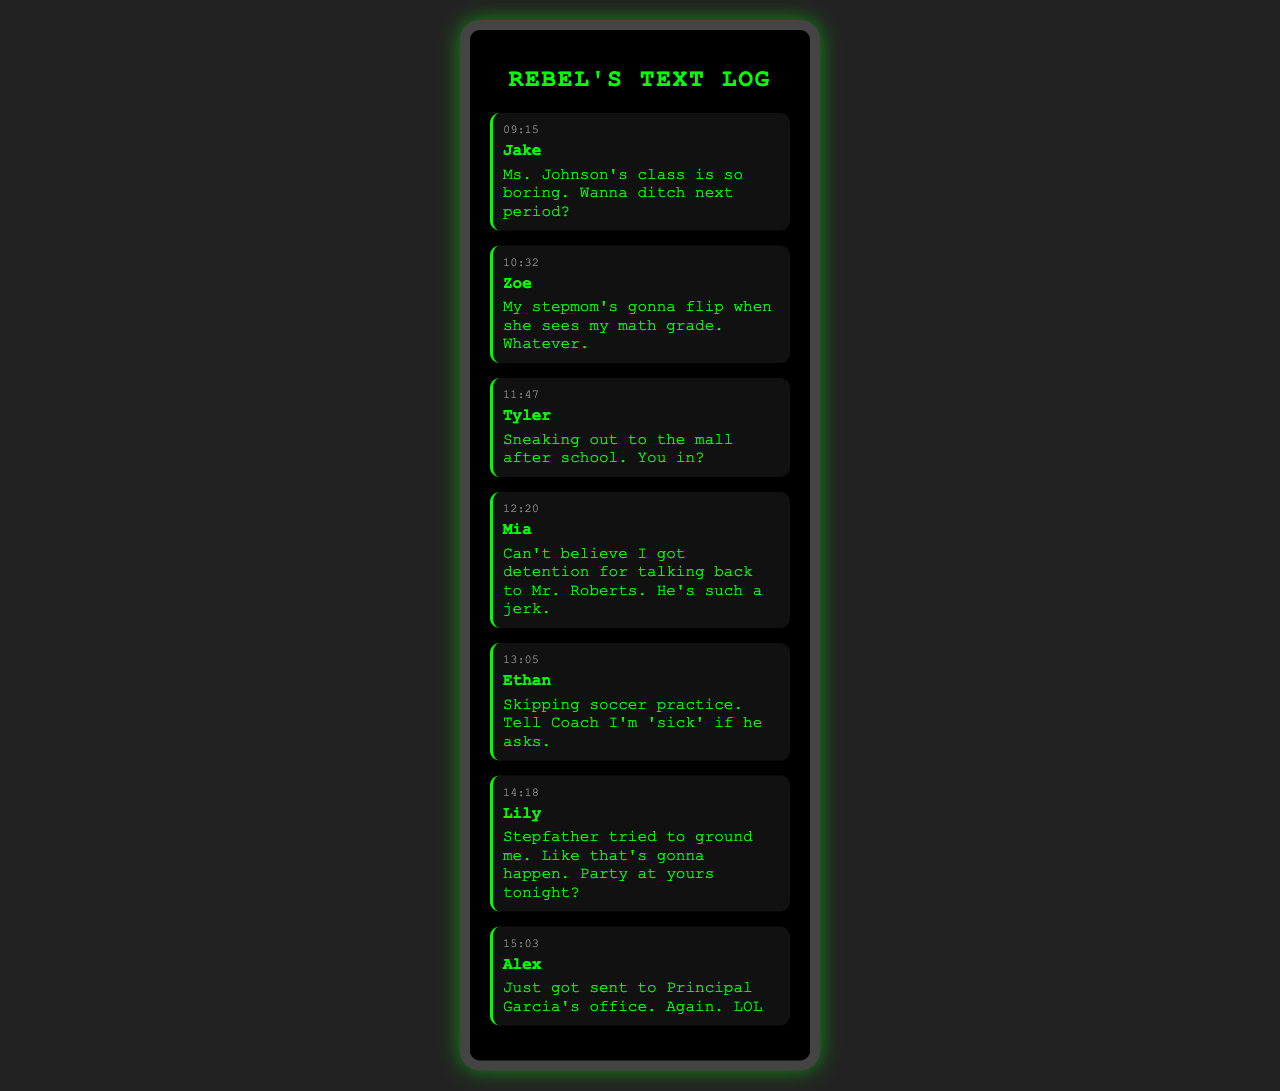What time did the message to Jake get sent? The timestamp for the message sent to Jake is listed as 09:15.
Answer: 09:15 Who is the recipient of the message about detention? The recipient of the message discussing detention is Mia.
Answer: Mia What did Ethan plan to tell Coach if asked about skipping practice? Ethan planned to tell Coach he was 'sick' if asked about skipping soccer practice.
Answer: 'sick' How many messages were sent during school hours? There are a total of 7 messages displayed in the document from different recipients during school hours.
Answer: 7 Which friend mentioned a party? The friend who mentioned a party is Lily.
Answer: Lily What is the message content that expresses frustration about a teacher? The message content expressing frustration by Mia about a teacher is that she can't believe she got detention for talking back to Mr. Roberts.
Answer: Can't believe I got detention for talking back to Mr. Roberts Who is mentioned as having a bad math grade? The person mentioned as having a bad math grade is the sender of the message, which is Zoe.
Answer: Zoe 